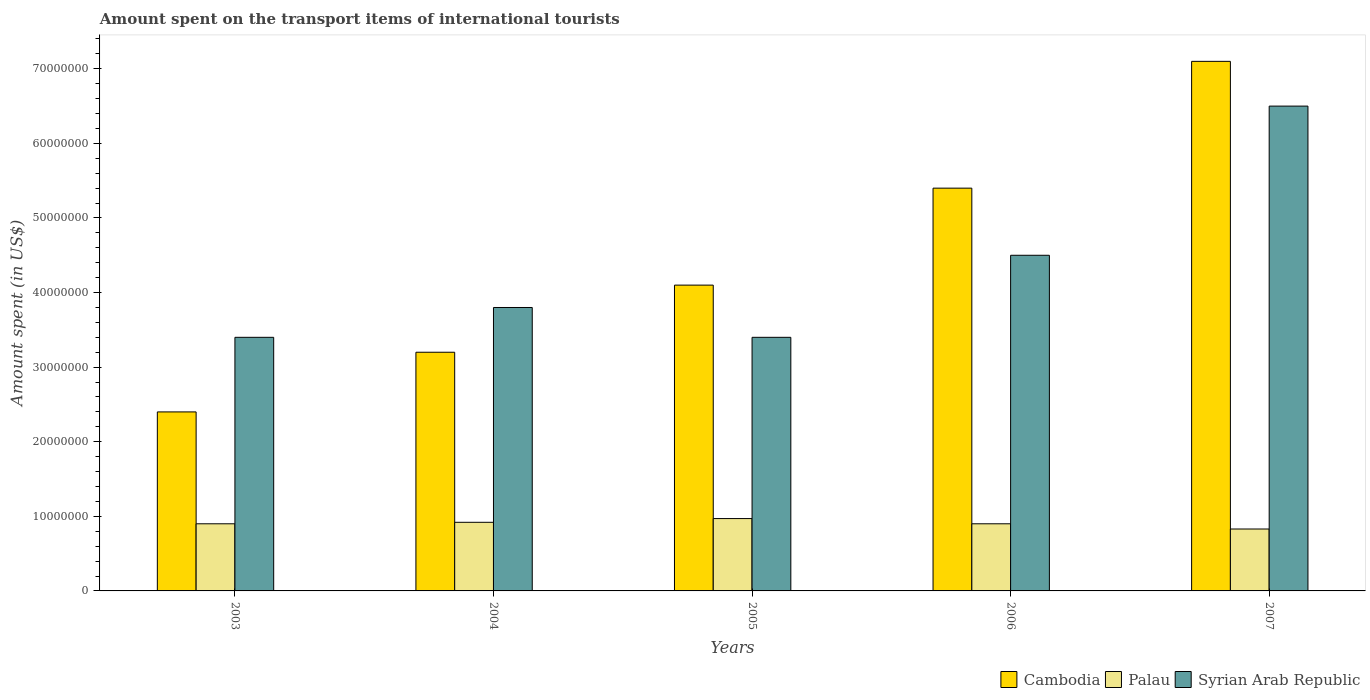Are the number of bars on each tick of the X-axis equal?
Ensure brevity in your answer.  Yes. What is the label of the 3rd group of bars from the left?
Offer a terse response. 2005. What is the amount spent on the transport items of international tourists in Syrian Arab Republic in 2004?
Your answer should be very brief. 3.80e+07. Across all years, what is the maximum amount spent on the transport items of international tourists in Palau?
Provide a succinct answer. 9.70e+06. Across all years, what is the minimum amount spent on the transport items of international tourists in Palau?
Offer a terse response. 8.30e+06. In which year was the amount spent on the transport items of international tourists in Palau maximum?
Offer a very short reply. 2005. What is the total amount spent on the transport items of international tourists in Syrian Arab Republic in the graph?
Provide a short and direct response. 2.16e+08. What is the difference between the amount spent on the transport items of international tourists in Palau in 2005 and the amount spent on the transport items of international tourists in Cambodia in 2004?
Your answer should be compact. -2.23e+07. What is the average amount spent on the transport items of international tourists in Syrian Arab Republic per year?
Provide a short and direct response. 4.32e+07. In the year 2005, what is the difference between the amount spent on the transport items of international tourists in Palau and amount spent on the transport items of international tourists in Cambodia?
Your answer should be very brief. -3.13e+07. In how many years, is the amount spent on the transport items of international tourists in Cambodia greater than 48000000 US$?
Your answer should be compact. 2. What is the ratio of the amount spent on the transport items of international tourists in Palau in 2003 to that in 2005?
Offer a very short reply. 0.93. What is the difference between the highest and the second highest amount spent on the transport items of international tourists in Syrian Arab Republic?
Keep it short and to the point. 2.00e+07. What is the difference between the highest and the lowest amount spent on the transport items of international tourists in Palau?
Offer a terse response. 1.40e+06. In how many years, is the amount spent on the transport items of international tourists in Syrian Arab Republic greater than the average amount spent on the transport items of international tourists in Syrian Arab Republic taken over all years?
Provide a short and direct response. 2. Is the sum of the amount spent on the transport items of international tourists in Palau in 2003 and 2007 greater than the maximum amount spent on the transport items of international tourists in Cambodia across all years?
Your response must be concise. No. What does the 2nd bar from the left in 2007 represents?
Provide a succinct answer. Palau. What does the 2nd bar from the right in 2004 represents?
Offer a very short reply. Palau. Is it the case that in every year, the sum of the amount spent on the transport items of international tourists in Cambodia and amount spent on the transport items of international tourists in Palau is greater than the amount spent on the transport items of international tourists in Syrian Arab Republic?
Offer a very short reply. No. How many bars are there?
Your answer should be very brief. 15. What is the difference between two consecutive major ticks on the Y-axis?
Offer a terse response. 1.00e+07. Does the graph contain grids?
Make the answer very short. No. How are the legend labels stacked?
Make the answer very short. Horizontal. What is the title of the graph?
Your response must be concise. Amount spent on the transport items of international tourists. Does "Mali" appear as one of the legend labels in the graph?
Offer a terse response. No. What is the label or title of the X-axis?
Ensure brevity in your answer.  Years. What is the label or title of the Y-axis?
Offer a very short reply. Amount spent (in US$). What is the Amount spent (in US$) in Cambodia in 2003?
Offer a very short reply. 2.40e+07. What is the Amount spent (in US$) in Palau in 2003?
Offer a very short reply. 9.00e+06. What is the Amount spent (in US$) of Syrian Arab Republic in 2003?
Offer a very short reply. 3.40e+07. What is the Amount spent (in US$) of Cambodia in 2004?
Give a very brief answer. 3.20e+07. What is the Amount spent (in US$) of Palau in 2004?
Ensure brevity in your answer.  9.20e+06. What is the Amount spent (in US$) in Syrian Arab Republic in 2004?
Give a very brief answer. 3.80e+07. What is the Amount spent (in US$) of Cambodia in 2005?
Give a very brief answer. 4.10e+07. What is the Amount spent (in US$) of Palau in 2005?
Make the answer very short. 9.70e+06. What is the Amount spent (in US$) in Syrian Arab Republic in 2005?
Ensure brevity in your answer.  3.40e+07. What is the Amount spent (in US$) of Cambodia in 2006?
Ensure brevity in your answer.  5.40e+07. What is the Amount spent (in US$) of Palau in 2006?
Your response must be concise. 9.00e+06. What is the Amount spent (in US$) of Syrian Arab Republic in 2006?
Offer a very short reply. 4.50e+07. What is the Amount spent (in US$) of Cambodia in 2007?
Keep it short and to the point. 7.10e+07. What is the Amount spent (in US$) in Palau in 2007?
Ensure brevity in your answer.  8.30e+06. What is the Amount spent (in US$) of Syrian Arab Republic in 2007?
Keep it short and to the point. 6.50e+07. Across all years, what is the maximum Amount spent (in US$) of Cambodia?
Your answer should be compact. 7.10e+07. Across all years, what is the maximum Amount spent (in US$) of Palau?
Your response must be concise. 9.70e+06. Across all years, what is the maximum Amount spent (in US$) of Syrian Arab Republic?
Ensure brevity in your answer.  6.50e+07. Across all years, what is the minimum Amount spent (in US$) in Cambodia?
Provide a succinct answer. 2.40e+07. Across all years, what is the minimum Amount spent (in US$) of Palau?
Ensure brevity in your answer.  8.30e+06. Across all years, what is the minimum Amount spent (in US$) in Syrian Arab Republic?
Provide a succinct answer. 3.40e+07. What is the total Amount spent (in US$) of Cambodia in the graph?
Offer a very short reply. 2.22e+08. What is the total Amount spent (in US$) in Palau in the graph?
Offer a terse response. 4.52e+07. What is the total Amount spent (in US$) in Syrian Arab Republic in the graph?
Keep it short and to the point. 2.16e+08. What is the difference between the Amount spent (in US$) in Cambodia in 2003 and that in 2004?
Your response must be concise. -8.00e+06. What is the difference between the Amount spent (in US$) in Palau in 2003 and that in 2004?
Make the answer very short. -2.00e+05. What is the difference between the Amount spent (in US$) in Syrian Arab Republic in 2003 and that in 2004?
Provide a succinct answer. -4.00e+06. What is the difference between the Amount spent (in US$) of Cambodia in 2003 and that in 2005?
Provide a succinct answer. -1.70e+07. What is the difference between the Amount spent (in US$) of Palau in 2003 and that in 2005?
Your response must be concise. -7.00e+05. What is the difference between the Amount spent (in US$) of Syrian Arab Republic in 2003 and that in 2005?
Your answer should be very brief. 0. What is the difference between the Amount spent (in US$) in Cambodia in 2003 and that in 2006?
Make the answer very short. -3.00e+07. What is the difference between the Amount spent (in US$) in Palau in 2003 and that in 2006?
Provide a short and direct response. 0. What is the difference between the Amount spent (in US$) in Syrian Arab Republic in 2003 and that in 2006?
Your answer should be compact. -1.10e+07. What is the difference between the Amount spent (in US$) of Cambodia in 2003 and that in 2007?
Offer a very short reply. -4.70e+07. What is the difference between the Amount spent (in US$) of Syrian Arab Republic in 2003 and that in 2007?
Your answer should be compact. -3.10e+07. What is the difference between the Amount spent (in US$) in Cambodia in 2004 and that in 2005?
Keep it short and to the point. -9.00e+06. What is the difference between the Amount spent (in US$) in Palau in 2004 and that in 2005?
Give a very brief answer. -5.00e+05. What is the difference between the Amount spent (in US$) in Syrian Arab Republic in 2004 and that in 2005?
Your answer should be very brief. 4.00e+06. What is the difference between the Amount spent (in US$) of Cambodia in 2004 and that in 2006?
Offer a terse response. -2.20e+07. What is the difference between the Amount spent (in US$) in Syrian Arab Republic in 2004 and that in 2006?
Give a very brief answer. -7.00e+06. What is the difference between the Amount spent (in US$) of Cambodia in 2004 and that in 2007?
Offer a terse response. -3.90e+07. What is the difference between the Amount spent (in US$) in Palau in 2004 and that in 2007?
Provide a short and direct response. 9.00e+05. What is the difference between the Amount spent (in US$) of Syrian Arab Republic in 2004 and that in 2007?
Provide a succinct answer. -2.70e+07. What is the difference between the Amount spent (in US$) of Cambodia in 2005 and that in 2006?
Your response must be concise. -1.30e+07. What is the difference between the Amount spent (in US$) of Syrian Arab Republic in 2005 and that in 2006?
Your answer should be compact. -1.10e+07. What is the difference between the Amount spent (in US$) in Cambodia in 2005 and that in 2007?
Provide a short and direct response. -3.00e+07. What is the difference between the Amount spent (in US$) in Palau in 2005 and that in 2007?
Provide a succinct answer. 1.40e+06. What is the difference between the Amount spent (in US$) in Syrian Arab Republic in 2005 and that in 2007?
Your answer should be very brief. -3.10e+07. What is the difference between the Amount spent (in US$) of Cambodia in 2006 and that in 2007?
Your response must be concise. -1.70e+07. What is the difference between the Amount spent (in US$) in Syrian Arab Republic in 2006 and that in 2007?
Your answer should be compact. -2.00e+07. What is the difference between the Amount spent (in US$) of Cambodia in 2003 and the Amount spent (in US$) of Palau in 2004?
Keep it short and to the point. 1.48e+07. What is the difference between the Amount spent (in US$) in Cambodia in 2003 and the Amount spent (in US$) in Syrian Arab Republic in 2004?
Your response must be concise. -1.40e+07. What is the difference between the Amount spent (in US$) of Palau in 2003 and the Amount spent (in US$) of Syrian Arab Republic in 2004?
Offer a terse response. -2.90e+07. What is the difference between the Amount spent (in US$) in Cambodia in 2003 and the Amount spent (in US$) in Palau in 2005?
Ensure brevity in your answer.  1.43e+07. What is the difference between the Amount spent (in US$) in Cambodia in 2003 and the Amount spent (in US$) in Syrian Arab Republic in 2005?
Provide a short and direct response. -1.00e+07. What is the difference between the Amount spent (in US$) of Palau in 2003 and the Amount spent (in US$) of Syrian Arab Republic in 2005?
Ensure brevity in your answer.  -2.50e+07. What is the difference between the Amount spent (in US$) of Cambodia in 2003 and the Amount spent (in US$) of Palau in 2006?
Ensure brevity in your answer.  1.50e+07. What is the difference between the Amount spent (in US$) of Cambodia in 2003 and the Amount spent (in US$) of Syrian Arab Republic in 2006?
Provide a succinct answer. -2.10e+07. What is the difference between the Amount spent (in US$) in Palau in 2003 and the Amount spent (in US$) in Syrian Arab Republic in 2006?
Give a very brief answer. -3.60e+07. What is the difference between the Amount spent (in US$) of Cambodia in 2003 and the Amount spent (in US$) of Palau in 2007?
Keep it short and to the point. 1.57e+07. What is the difference between the Amount spent (in US$) of Cambodia in 2003 and the Amount spent (in US$) of Syrian Arab Republic in 2007?
Ensure brevity in your answer.  -4.10e+07. What is the difference between the Amount spent (in US$) in Palau in 2003 and the Amount spent (in US$) in Syrian Arab Republic in 2007?
Your answer should be very brief. -5.60e+07. What is the difference between the Amount spent (in US$) of Cambodia in 2004 and the Amount spent (in US$) of Palau in 2005?
Give a very brief answer. 2.23e+07. What is the difference between the Amount spent (in US$) of Palau in 2004 and the Amount spent (in US$) of Syrian Arab Republic in 2005?
Provide a succinct answer. -2.48e+07. What is the difference between the Amount spent (in US$) of Cambodia in 2004 and the Amount spent (in US$) of Palau in 2006?
Your answer should be compact. 2.30e+07. What is the difference between the Amount spent (in US$) in Cambodia in 2004 and the Amount spent (in US$) in Syrian Arab Republic in 2006?
Offer a terse response. -1.30e+07. What is the difference between the Amount spent (in US$) of Palau in 2004 and the Amount spent (in US$) of Syrian Arab Republic in 2006?
Keep it short and to the point. -3.58e+07. What is the difference between the Amount spent (in US$) of Cambodia in 2004 and the Amount spent (in US$) of Palau in 2007?
Offer a very short reply. 2.37e+07. What is the difference between the Amount spent (in US$) of Cambodia in 2004 and the Amount spent (in US$) of Syrian Arab Republic in 2007?
Your answer should be compact. -3.30e+07. What is the difference between the Amount spent (in US$) in Palau in 2004 and the Amount spent (in US$) in Syrian Arab Republic in 2007?
Keep it short and to the point. -5.58e+07. What is the difference between the Amount spent (in US$) in Cambodia in 2005 and the Amount spent (in US$) in Palau in 2006?
Give a very brief answer. 3.20e+07. What is the difference between the Amount spent (in US$) of Cambodia in 2005 and the Amount spent (in US$) of Syrian Arab Republic in 2006?
Your answer should be compact. -4.00e+06. What is the difference between the Amount spent (in US$) in Palau in 2005 and the Amount spent (in US$) in Syrian Arab Republic in 2006?
Your response must be concise. -3.53e+07. What is the difference between the Amount spent (in US$) in Cambodia in 2005 and the Amount spent (in US$) in Palau in 2007?
Offer a very short reply. 3.27e+07. What is the difference between the Amount spent (in US$) of Cambodia in 2005 and the Amount spent (in US$) of Syrian Arab Republic in 2007?
Keep it short and to the point. -2.40e+07. What is the difference between the Amount spent (in US$) of Palau in 2005 and the Amount spent (in US$) of Syrian Arab Republic in 2007?
Offer a very short reply. -5.53e+07. What is the difference between the Amount spent (in US$) in Cambodia in 2006 and the Amount spent (in US$) in Palau in 2007?
Offer a terse response. 4.57e+07. What is the difference between the Amount spent (in US$) of Cambodia in 2006 and the Amount spent (in US$) of Syrian Arab Republic in 2007?
Your response must be concise. -1.10e+07. What is the difference between the Amount spent (in US$) in Palau in 2006 and the Amount spent (in US$) in Syrian Arab Republic in 2007?
Provide a succinct answer. -5.60e+07. What is the average Amount spent (in US$) in Cambodia per year?
Your answer should be compact. 4.44e+07. What is the average Amount spent (in US$) in Palau per year?
Provide a succinct answer. 9.04e+06. What is the average Amount spent (in US$) of Syrian Arab Republic per year?
Offer a terse response. 4.32e+07. In the year 2003, what is the difference between the Amount spent (in US$) of Cambodia and Amount spent (in US$) of Palau?
Ensure brevity in your answer.  1.50e+07. In the year 2003, what is the difference between the Amount spent (in US$) in Cambodia and Amount spent (in US$) in Syrian Arab Republic?
Provide a succinct answer. -1.00e+07. In the year 2003, what is the difference between the Amount spent (in US$) of Palau and Amount spent (in US$) of Syrian Arab Republic?
Ensure brevity in your answer.  -2.50e+07. In the year 2004, what is the difference between the Amount spent (in US$) of Cambodia and Amount spent (in US$) of Palau?
Your answer should be very brief. 2.28e+07. In the year 2004, what is the difference between the Amount spent (in US$) in Cambodia and Amount spent (in US$) in Syrian Arab Republic?
Give a very brief answer. -6.00e+06. In the year 2004, what is the difference between the Amount spent (in US$) of Palau and Amount spent (in US$) of Syrian Arab Republic?
Your answer should be compact. -2.88e+07. In the year 2005, what is the difference between the Amount spent (in US$) in Cambodia and Amount spent (in US$) in Palau?
Ensure brevity in your answer.  3.13e+07. In the year 2005, what is the difference between the Amount spent (in US$) in Palau and Amount spent (in US$) in Syrian Arab Republic?
Ensure brevity in your answer.  -2.43e+07. In the year 2006, what is the difference between the Amount spent (in US$) in Cambodia and Amount spent (in US$) in Palau?
Your answer should be compact. 4.50e+07. In the year 2006, what is the difference between the Amount spent (in US$) in Cambodia and Amount spent (in US$) in Syrian Arab Republic?
Make the answer very short. 9.00e+06. In the year 2006, what is the difference between the Amount spent (in US$) in Palau and Amount spent (in US$) in Syrian Arab Republic?
Offer a terse response. -3.60e+07. In the year 2007, what is the difference between the Amount spent (in US$) of Cambodia and Amount spent (in US$) of Palau?
Offer a very short reply. 6.27e+07. In the year 2007, what is the difference between the Amount spent (in US$) of Cambodia and Amount spent (in US$) of Syrian Arab Republic?
Provide a succinct answer. 6.00e+06. In the year 2007, what is the difference between the Amount spent (in US$) in Palau and Amount spent (in US$) in Syrian Arab Republic?
Ensure brevity in your answer.  -5.67e+07. What is the ratio of the Amount spent (in US$) in Palau in 2003 to that in 2004?
Offer a very short reply. 0.98. What is the ratio of the Amount spent (in US$) in Syrian Arab Republic in 2003 to that in 2004?
Your response must be concise. 0.89. What is the ratio of the Amount spent (in US$) of Cambodia in 2003 to that in 2005?
Provide a succinct answer. 0.59. What is the ratio of the Amount spent (in US$) in Palau in 2003 to that in 2005?
Give a very brief answer. 0.93. What is the ratio of the Amount spent (in US$) in Syrian Arab Republic in 2003 to that in 2005?
Make the answer very short. 1. What is the ratio of the Amount spent (in US$) in Cambodia in 2003 to that in 2006?
Offer a terse response. 0.44. What is the ratio of the Amount spent (in US$) of Palau in 2003 to that in 2006?
Offer a terse response. 1. What is the ratio of the Amount spent (in US$) in Syrian Arab Republic in 2003 to that in 2006?
Provide a short and direct response. 0.76. What is the ratio of the Amount spent (in US$) in Cambodia in 2003 to that in 2007?
Provide a short and direct response. 0.34. What is the ratio of the Amount spent (in US$) in Palau in 2003 to that in 2007?
Ensure brevity in your answer.  1.08. What is the ratio of the Amount spent (in US$) of Syrian Arab Republic in 2003 to that in 2007?
Your answer should be very brief. 0.52. What is the ratio of the Amount spent (in US$) of Cambodia in 2004 to that in 2005?
Offer a very short reply. 0.78. What is the ratio of the Amount spent (in US$) in Palau in 2004 to that in 2005?
Your response must be concise. 0.95. What is the ratio of the Amount spent (in US$) of Syrian Arab Republic in 2004 to that in 2005?
Your response must be concise. 1.12. What is the ratio of the Amount spent (in US$) in Cambodia in 2004 to that in 2006?
Make the answer very short. 0.59. What is the ratio of the Amount spent (in US$) in Palau in 2004 to that in 2006?
Offer a very short reply. 1.02. What is the ratio of the Amount spent (in US$) of Syrian Arab Republic in 2004 to that in 2006?
Keep it short and to the point. 0.84. What is the ratio of the Amount spent (in US$) in Cambodia in 2004 to that in 2007?
Make the answer very short. 0.45. What is the ratio of the Amount spent (in US$) of Palau in 2004 to that in 2007?
Give a very brief answer. 1.11. What is the ratio of the Amount spent (in US$) in Syrian Arab Republic in 2004 to that in 2007?
Your answer should be compact. 0.58. What is the ratio of the Amount spent (in US$) in Cambodia in 2005 to that in 2006?
Provide a succinct answer. 0.76. What is the ratio of the Amount spent (in US$) in Palau in 2005 to that in 2006?
Give a very brief answer. 1.08. What is the ratio of the Amount spent (in US$) of Syrian Arab Republic in 2005 to that in 2006?
Your response must be concise. 0.76. What is the ratio of the Amount spent (in US$) in Cambodia in 2005 to that in 2007?
Provide a short and direct response. 0.58. What is the ratio of the Amount spent (in US$) of Palau in 2005 to that in 2007?
Make the answer very short. 1.17. What is the ratio of the Amount spent (in US$) of Syrian Arab Republic in 2005 to that in 2007?
Your response must be concise. 0.52. What is the ratio of the Amount spent (in US$) of Cambodia in 2006 to that in 2007?
Offer a terse response. 0.76. What is the ratio of the Amount spent (in US$) of Palau in 2006 to that in 2007?
Provide a succinct answer. 1.08. What is the ratio of the Amount spent (in US$) of Syrian Arab Republic in 2006 to that in 2007?
Your answer should be compact. 0.69. What is the difference between the highest and the second highest Amount spent (in US$) of Cambodia?
Provide a short and direct response. 1.70e+07. What is the difference between the highest and the second highest Amount spent (in US$) of Palau?
Offer a terse response. 5.00e+05. What is the difference between the highest and the lowest Amount spent (in US$) in Cambodia?
Ensure brevity in your answer.  4.70e+07. What is the difference between the highest and the lowest Amount spent (in US$) of Palau?
Offer a very short reply. 1.40e+06. What is the difference between the highest and the lowest Amount spent (in US$) in Syrian Arab Republic?
Ensure brevity in your answer.  3.10e+07. 